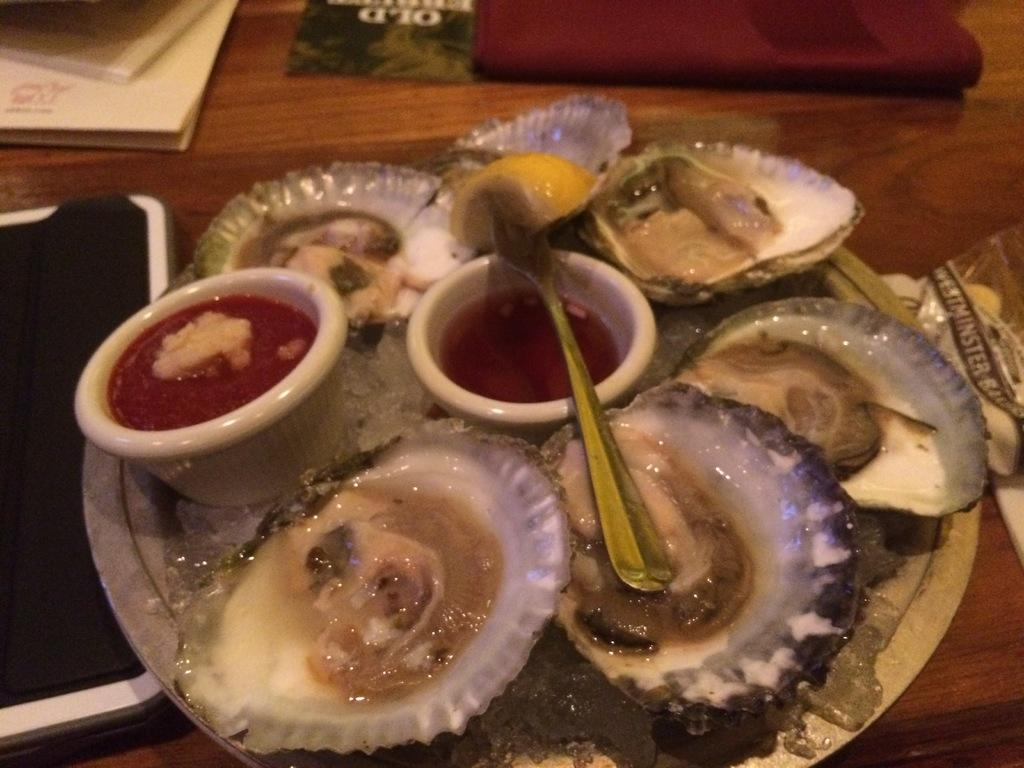What is present on the surface in the image? There is a plate in the image. What is on the plate in the image? There is food in the image. What type of containers are visible in the image? There are bowls in the image. What type of natural objects are present in the image? There are shells in the image. What is the surface made of that the objects are placed on? There are objects on a wooden platform in the image. What type of truck can be seen in the image? There is no truck present in the image. What type of bone is visible in the image? There is no bone present in the image. 